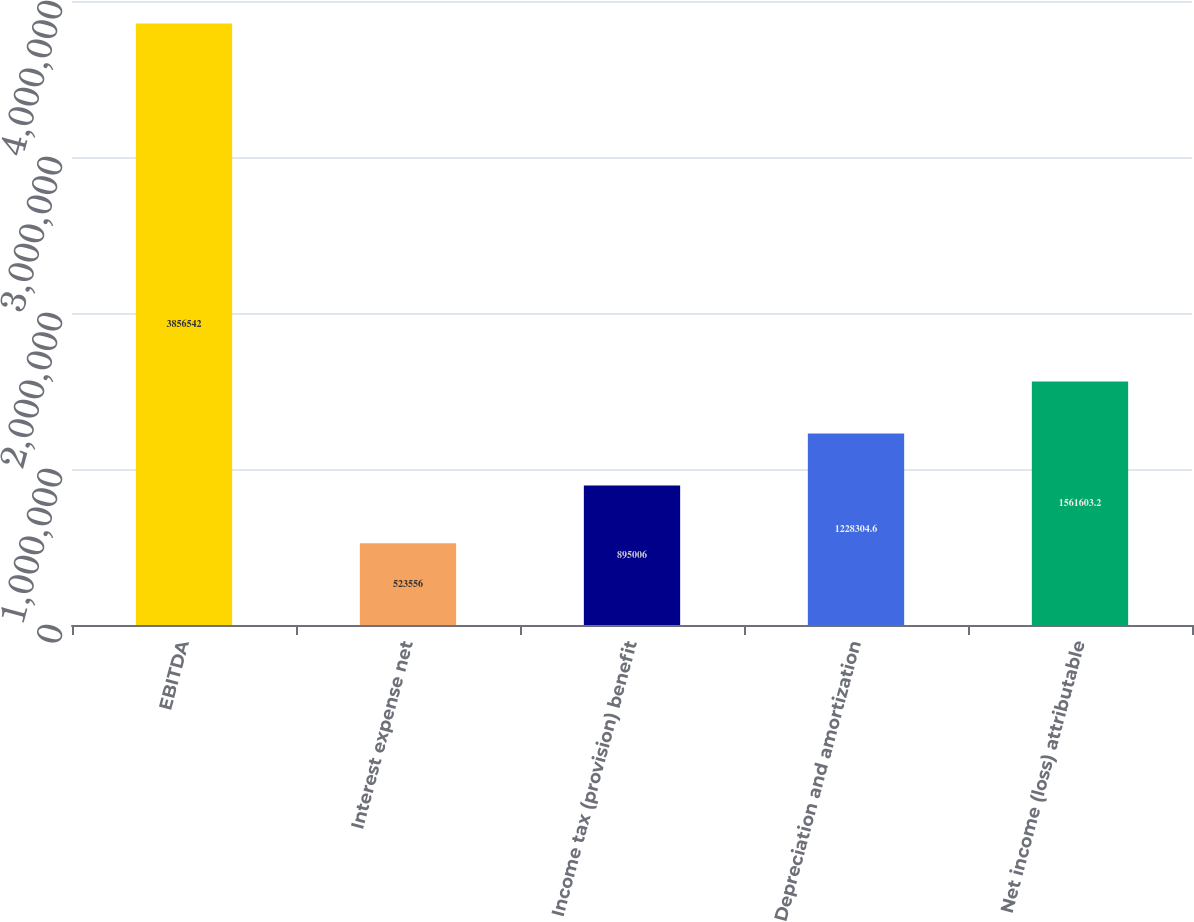<chart> <loc_0><loc_0><loc_500><loc_500><bar_chart><fcel>EBITDA<fcel>Interest expense net<fcel>Income tax (provision) benefit<fcel>Depreciation and amortization<fcel>Net income (loss) attributable<nl><fcel>3.85654e+06<fcel>523556<fcel>895006<fcel>1.2283e+06<fcel>1.5616e+06<nl></chart> 